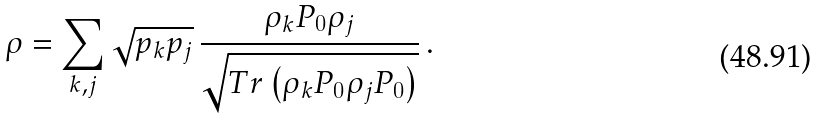<formula> <loc_0><loc_0><loc_500><loc_500>\rho = \sum _ { k , j } \sqrt { p _ { k } p _ { j } } \, \frac { \rho _ { k } P _ { 0 } \rho _ { j } } { \sqrt { T r \left ( \rho _ { k } P _ { 0 } \rho _ { j } P _ { 0 } \right ) } } \, .</formula> 